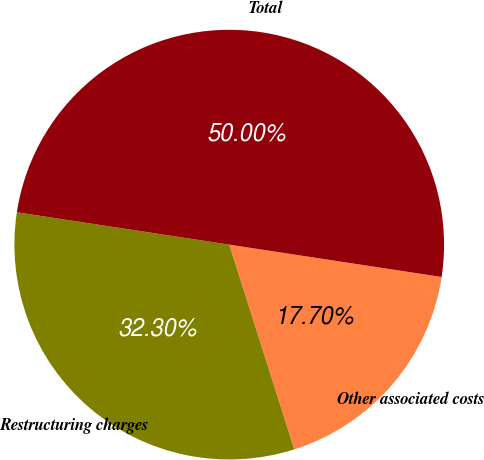Convert chart to OTSL. <chart><loc_0><loc_0><loc_500><loc_500><pie_chart><fcel>Other associated costs<fcel>Restructuring charges<fcel>Total<nl><fcel>17.7%<fcel>32.3%<fcel>50.0%<nl></chart> 